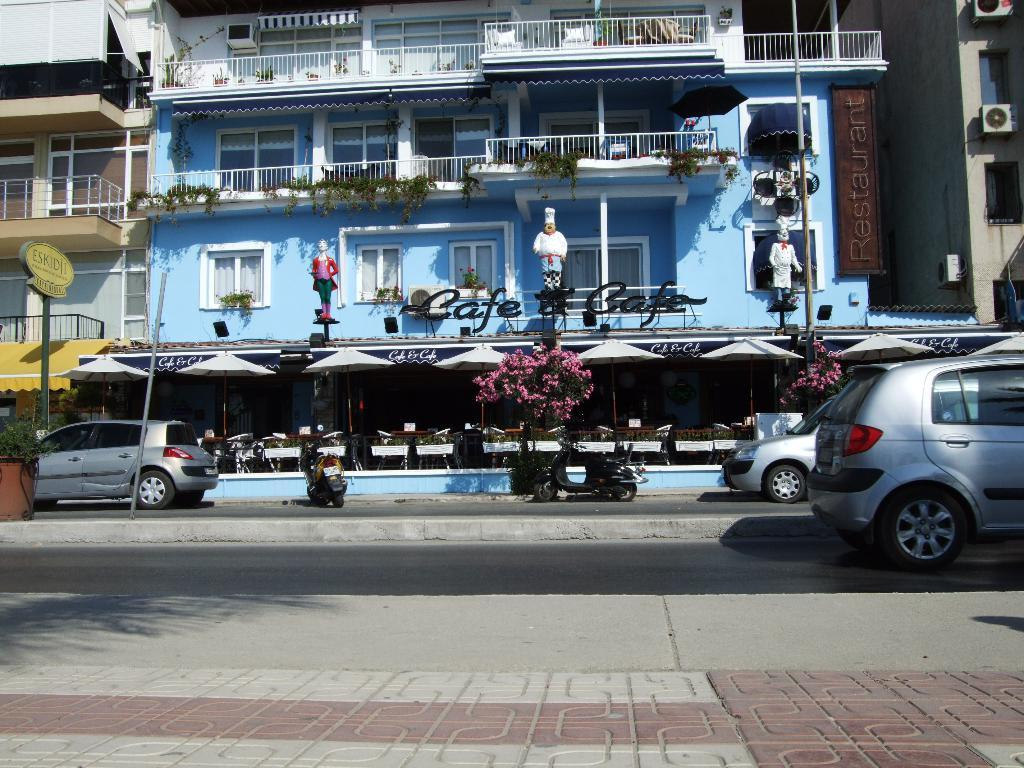What is the main subject of the image? The main subject of the image is a car on the road. Are there any other vehicles in the image? Yes, there are vehicles on a footpath in the image. What type of natural elements can be seen in the image? Trees are visible in the image. What objects might be used for protection from the elements in the image? Umbrellas are present in the image. What type of structures can be seen in the background of the image? There are buildings with windows in the background of the image. What type of head can be seen on the list in the library in the image? There is no list or library present in the image; it features a car on the road, vehicles on a footpath, trees, umbrellas, and buildings with windows in the background. 